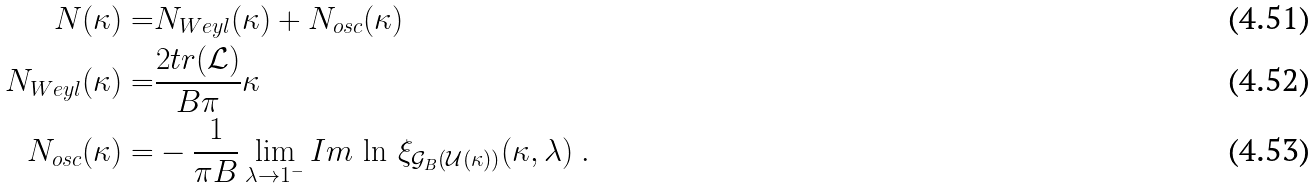<formula> <loc_0><loc_0><loc_500><loc_500>N ( \kappa ) = & N _ { W e y l } ( \kappa ) + N _ { o s c } ( \kappa ) \\ N _ { W e y l } ( \kappa ) = & \frac { 2 t r ( \mathcal { L } ) } { B \pi } \kappa \\ N _ { o s c } ( \kappa ) = & - \frac { 1 } { \pi B } \lim _ { \lambda \rightarrow 1 ^ { - } } I m \, \ln \, \xi _ { \mathcal { G } _ { B } ( \mathcal { U } ( \kappa ) ) } ( \kappa , \lambda ) \ .</formula> 